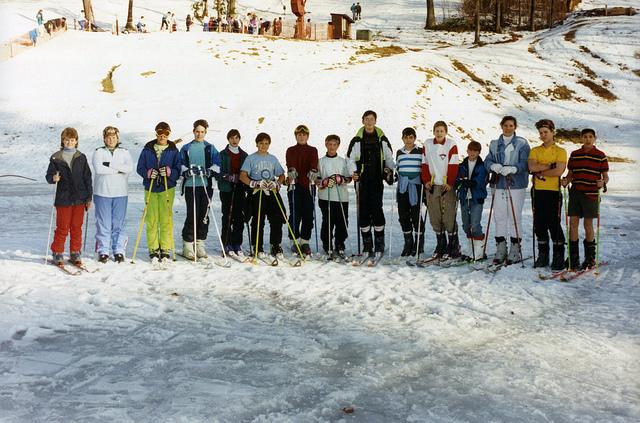How many people have ski gear?
Quick response, please. 15. What is the weather like?
Be succinct. Cold. Are there 15 people in this lineup?
Answer briefly. Yes. 